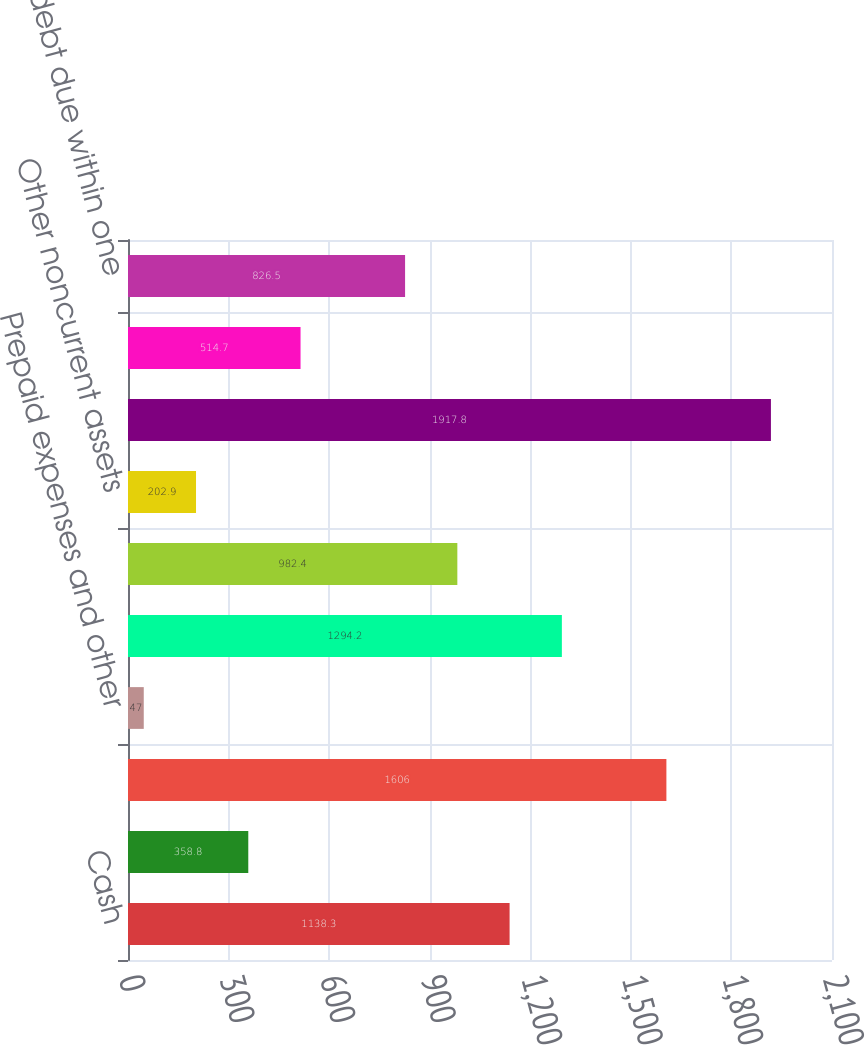Convert chart to OTSL. <chart><loc_0><loc_0><loc_500><loc_500><bar_chart><fcel>Cash<fcel>Receivables from customers<fcel>Inventories<fcel>Prepaid expenses and other<fcel>Properties plants and<fcel>Goodwill<fcel>Other noncurrent assets<fcel>Total assets<fcel>Other current liabilities<fcel>Long-term debt due within one<nl><fcel>1138.3<fcel>358.8<fcel>1606<fcel>47<fcel>1294.2<fcel>982.4<fcel>202.9<fcel>1917.8<fcel>514.7<fcel>826.5<nl></chart> 